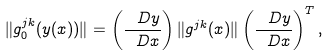Convert formula to latex. <formula><loc_0><loc_0><loc_500><loc_500>\| g _ { 0 } ^ { j k } ( y ( x ) ) \| = \left ( \frac { \ D y } { \ D x } \right ) \| g ^ { j k } ( x ) \| \left ( \frac { \ D y } { \ D x } \right ) ^ { T } ,</formula> 